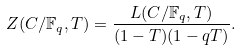Convert formula to latex. <formula><loc_0><loc_0><loc_500><loc_500>{ Z } ( C / \mathbb { F } _ { q } , T ) = \frac { L ( C / \mathbb { F } _ { q } , T ) } { ( 1 - T ) ( 1 - q T ) } .</formula> 